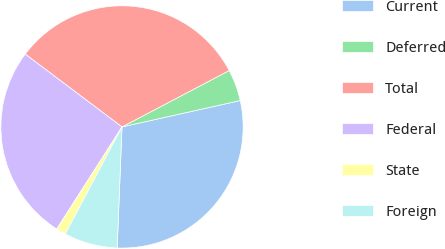Convert chart. <chart><loc_0><loc_0><loc_500><loc_500><pie_chart><fcel>Current<fcel>Deferred<fcel>Total<fcel>Federal<fcel>State<fcel>Foreign<nl><fcel>29.13%<fcel>4.21%<fcel>32.03%<fcel>26.22%<fcel>1.3%<fcel>7.12%<nl></chart> 